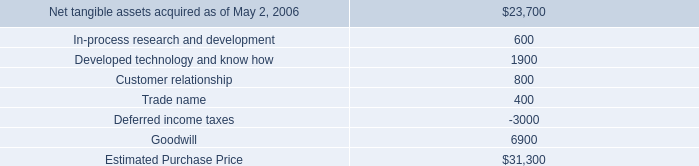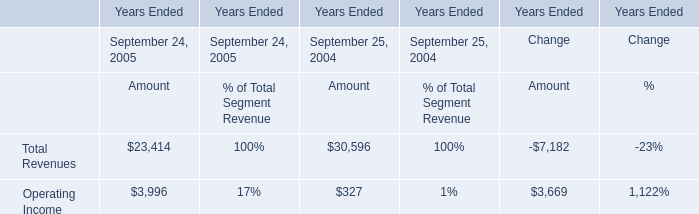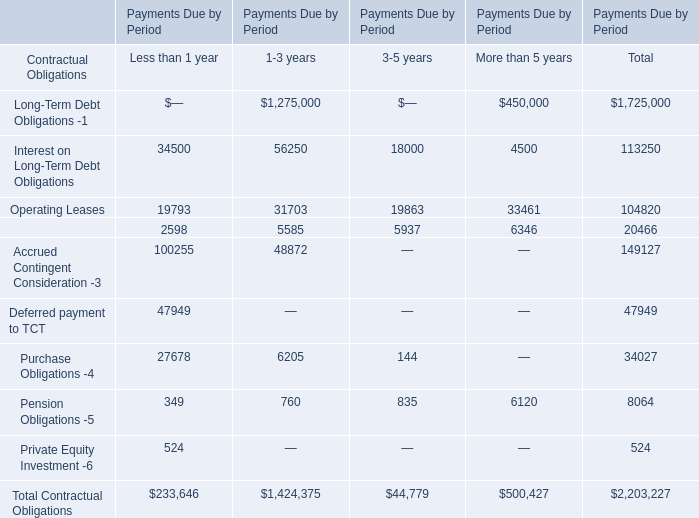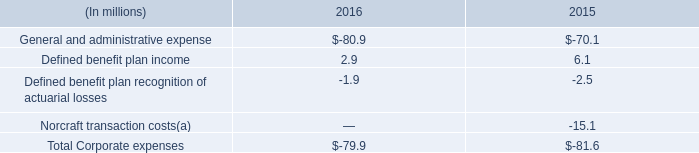what was the percentage growth in the general and administrative expense from 2015 to 2016 
Computations: ((80.9 - 70.1) / 70.1)
Answer: 0.15407. 